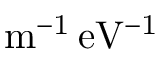<formula> <loc_0><loc_0><loc_500><loc_500>{ m ^ { - 1 } \, e V ^ { - 1 } }</formula> 